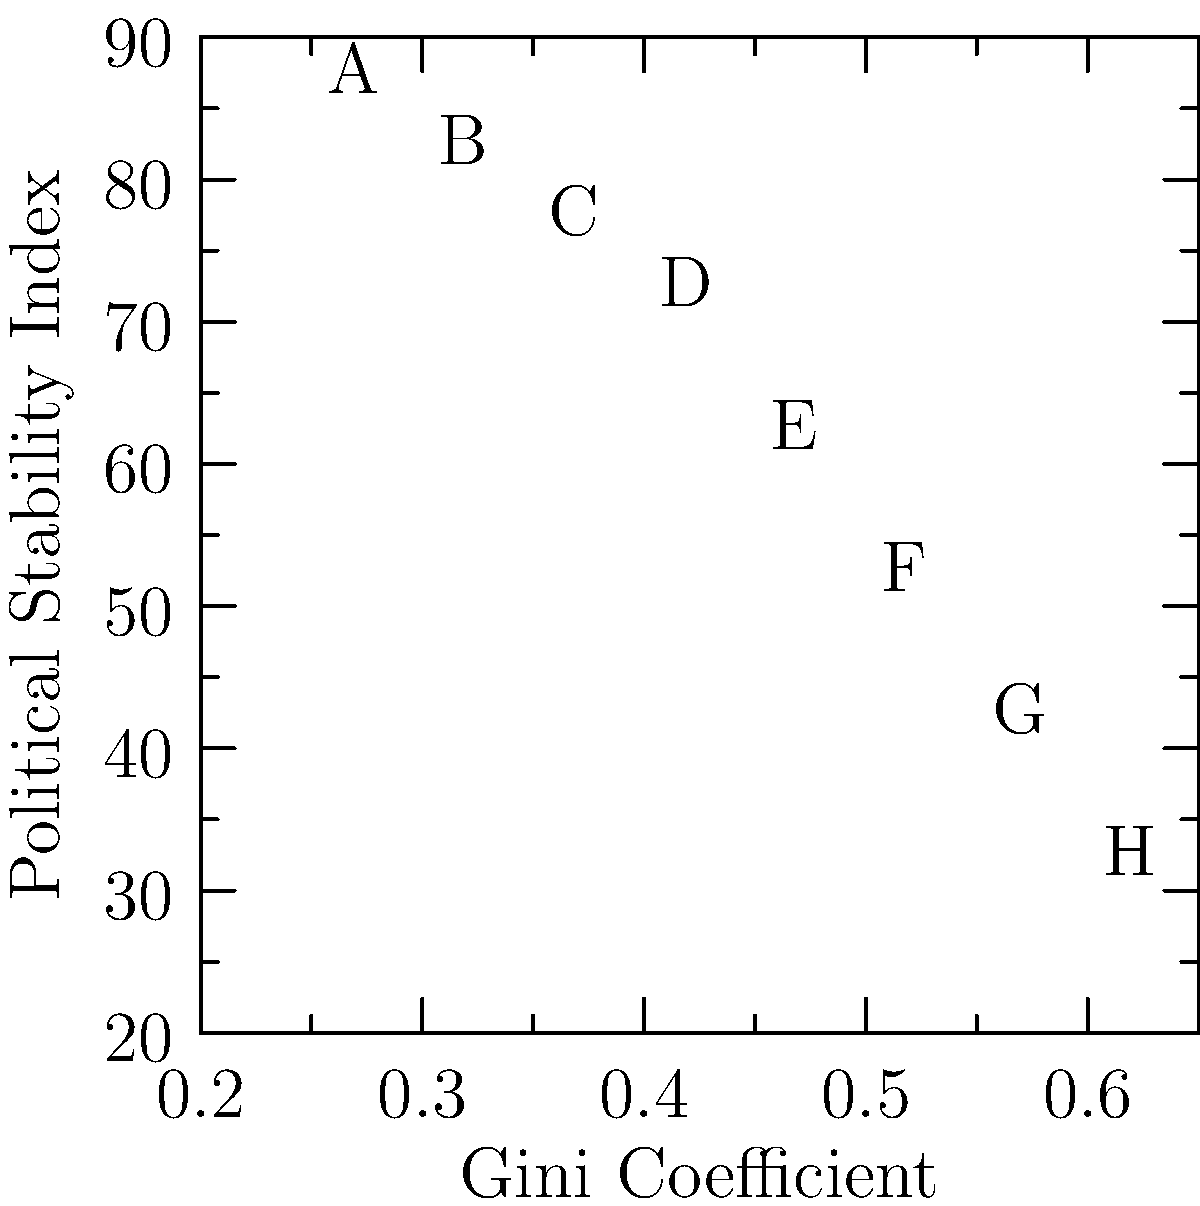Based on the scatter plot showing the relationship between Gini Coefficient (economic inequality) and Political Stability Index for various countries, what can be inferred about the correlation between economic inequality and political stability? How might this inform comparative politics research on the impact of economic factors on political conflicts? To analyze the correlation between economic inequality and political stability:

1. Observe the overall trend: As the Gini Coefficient increases (higher inequality), the Political Stability Index decreases.

2. Calculate the correlation coefficient:
   Using the formula: $r = \frac{\sum_{i=1}^{n} (x_i - \bar{x})(y_i - \bar{y})}{\sqrt{\sum_{i=1}^{n} (x_i - \bar{x})^2 \sum_{i=1}^{n} (y_i - \bar{y})^2}}$
   We find a strong negative correlation (approximately -0.99).

3. Interpret the correlation:
   The strong negative correlation suggests that as economic inequality increases, political stability tends to decrease significantly.

4. Consider outliers and clusters:
   There are no significant outliers, and the data points form a relatively consistent pattern.

5. Implications for comparative politics research:
   a) Economic inequality may be a strong predictor of political instability.
   b) Countries with higher Gini Coefficients might be more prone to political conflicts.
   c) Policies aimed at reducing economic inequality could potentially enhance political stability.
   d) The relationship appears to be linear, suggesting a consistent impact across different levels of inequality.

6. Limitations and further research:
   a) Consider other factors that might influence political stability (e.g., institutional strength, historical context).
   b) Investigate potential causal mechanisms linking inequality to instability.
   c) Examine case studies of countries at different points on the scatter plot to understand nuances.

This analysis provides a foundation for comparative studies on how economic factors, particularly inequality, may contribute to political conflicts and instability across different countries and political systems.
Answer: Strong negative correlation between economic inequality and political stability, suggesting higher inequality may lead to increased political instability and potential conflicts. 